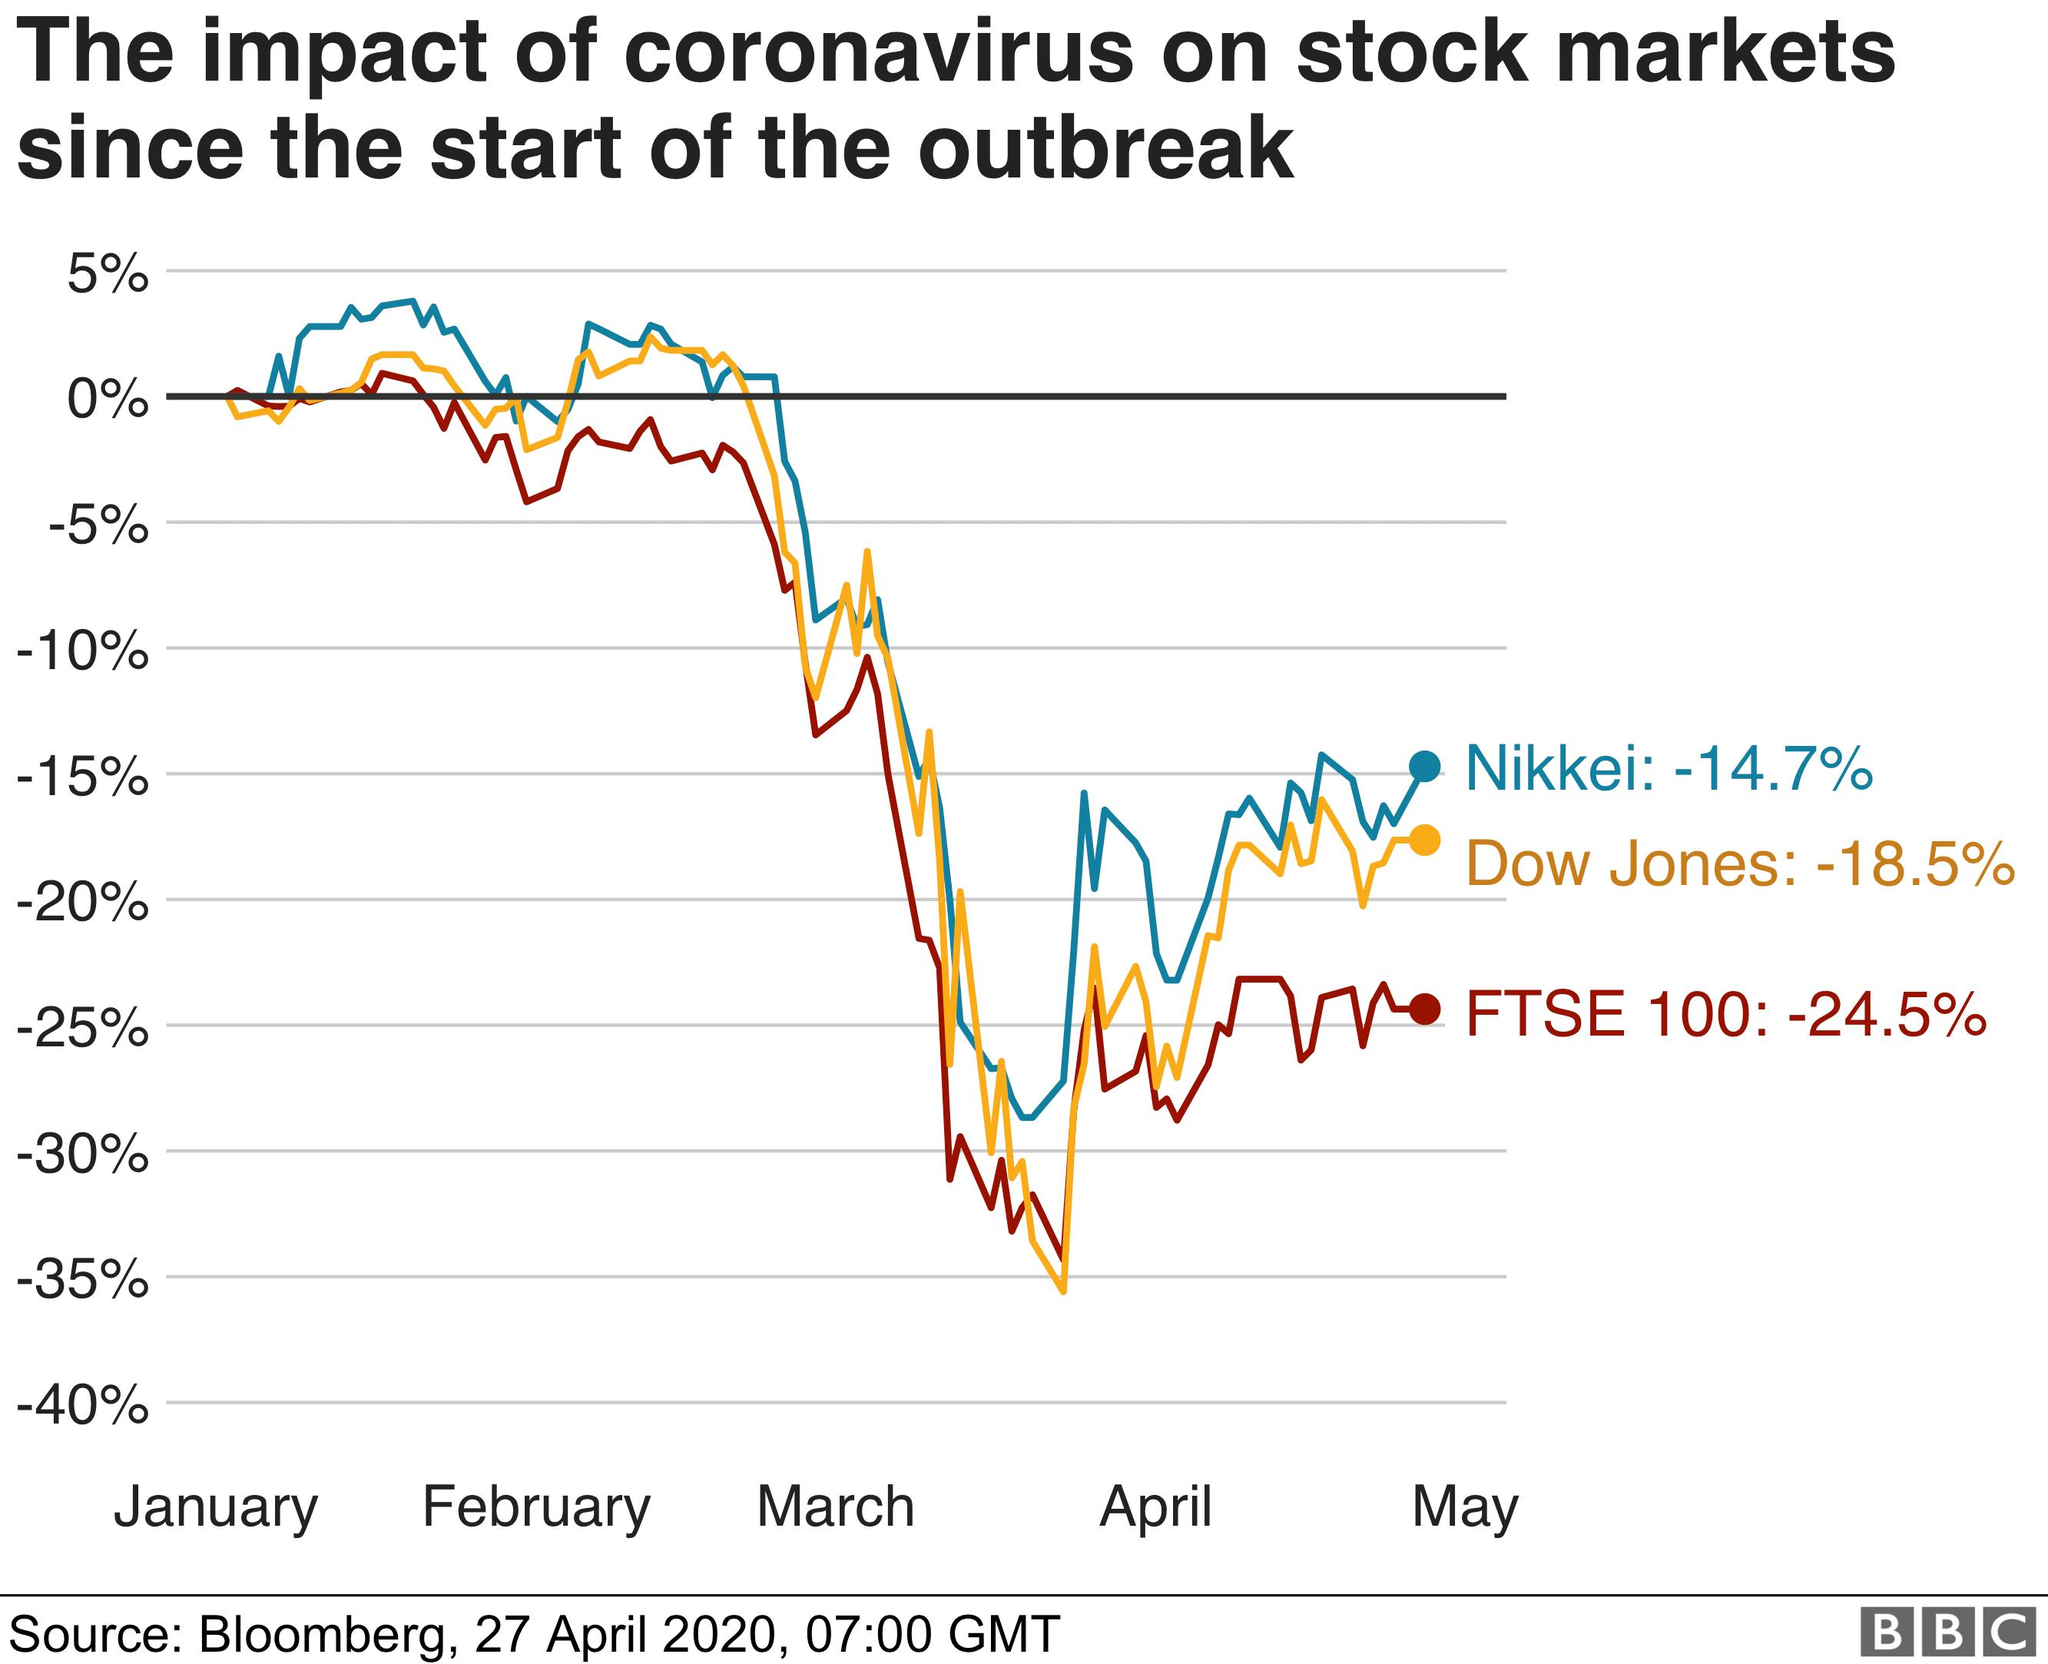Highlight a few significant elements in this photo. The Nikkei is represented by the color blue in a graph. There are three company names mentioned in the graph. The performance over the last five months is depicted in the graph. 